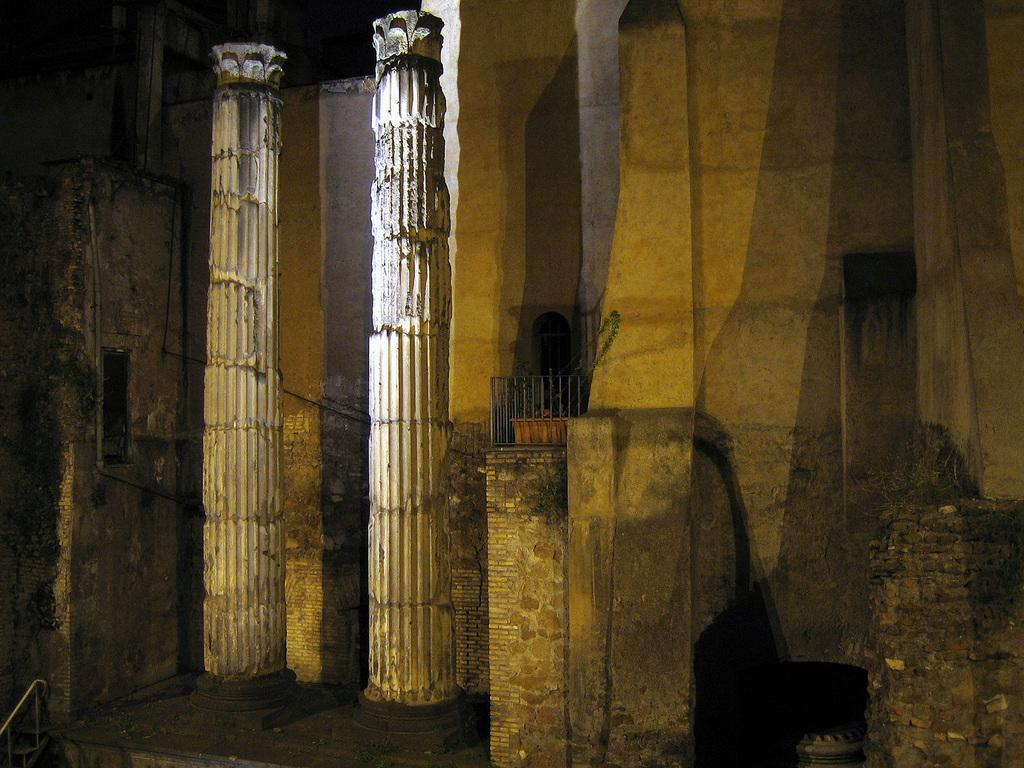What architectural elements can be seen in the image? There are pillars and a wall in the image. What other objects are present in the image? There is a grille and a plant pot in the image. What type of soup is being served for lunch in the image? There is no soup or lunch depicted in the image; it only features pillars, a wall, a grille, and a plant pot. 